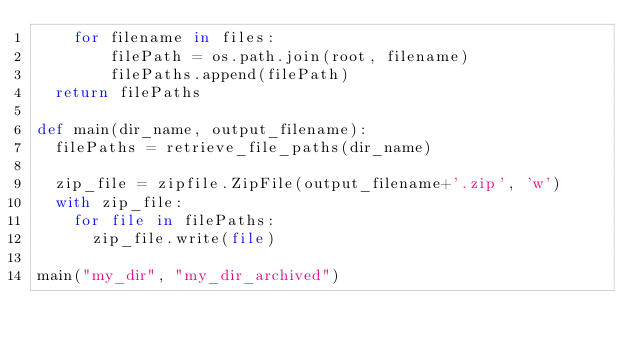<code> <loc_0><loc_0><loc_500><loc_500><_Python_>    for filename in files:
        filePath = os.path.join(root, filename)
        filePaths.append(filePath)
  return filePaths
 
def main(dir_name, output_filename):
  filePaths = retrieve_file_paths(dir_name)
   
  zip_file = zipfile.ZipFile(output_filename+'.zip', 'w')
  with zip_file:
    for file in filePaths:
      zip_file.write(file)

main("my_dir", "my_dir_archived")</code> 